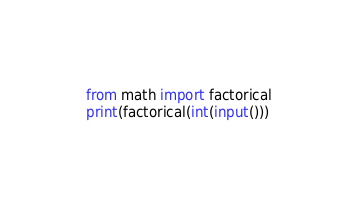Convert code to text. <code><loc_0><loc_0><loc_500><loc_500><_Python_>from math import factorical
print(factorical(int(input()))</code> 